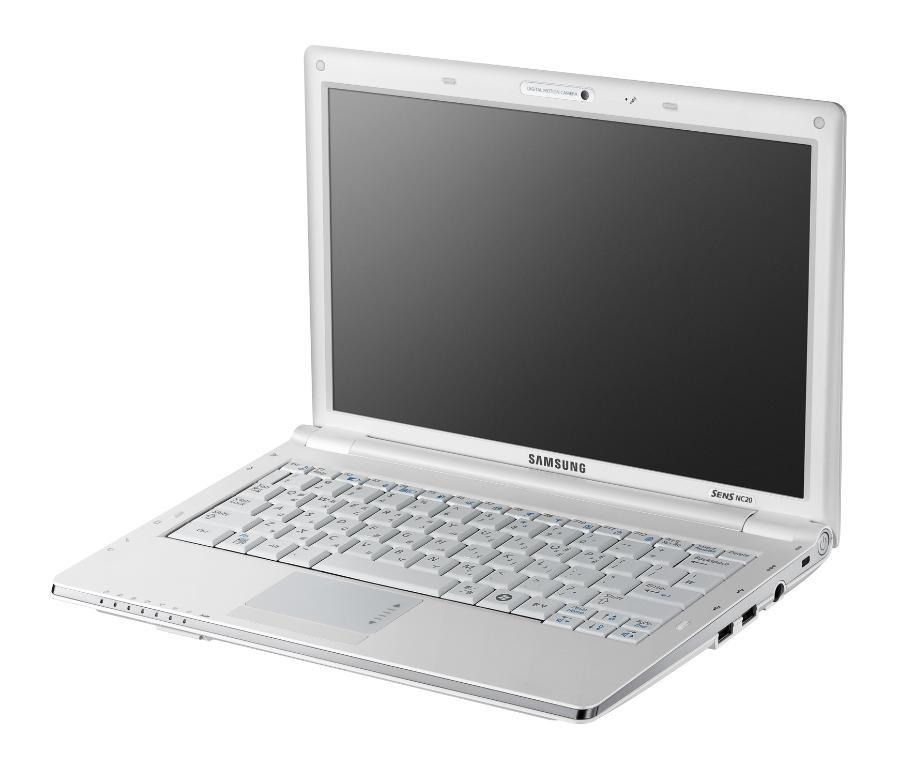Provide a one-sentence caption for the provided image. A Samsung laptop with a black screen in open. 